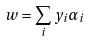Convert formula to latex. <formula><loc_0><loc_0><loc_500><loc_500>w = \sum _ { i } y _ { i } \alpha _ { i }</formula> 